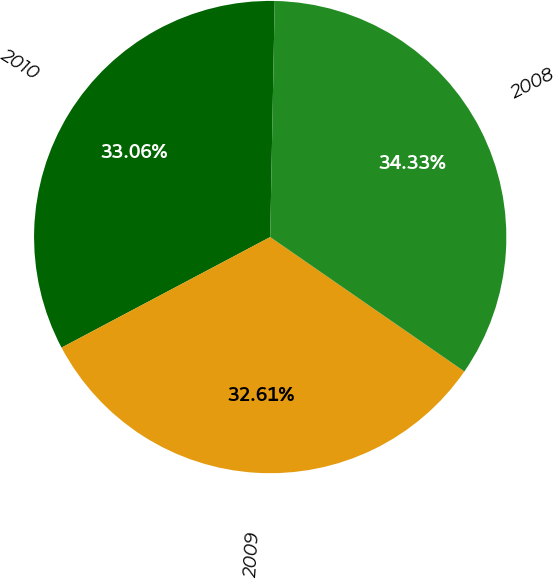Convert chart. <chart><loc_0><loc_0><loc_500><loc_500><pie_chart><fcel>2010<fcel>2009<fcel>2008<nl><fcel>33.06%<fcel>32.61%<fcel>34.33%<nl></chart> 